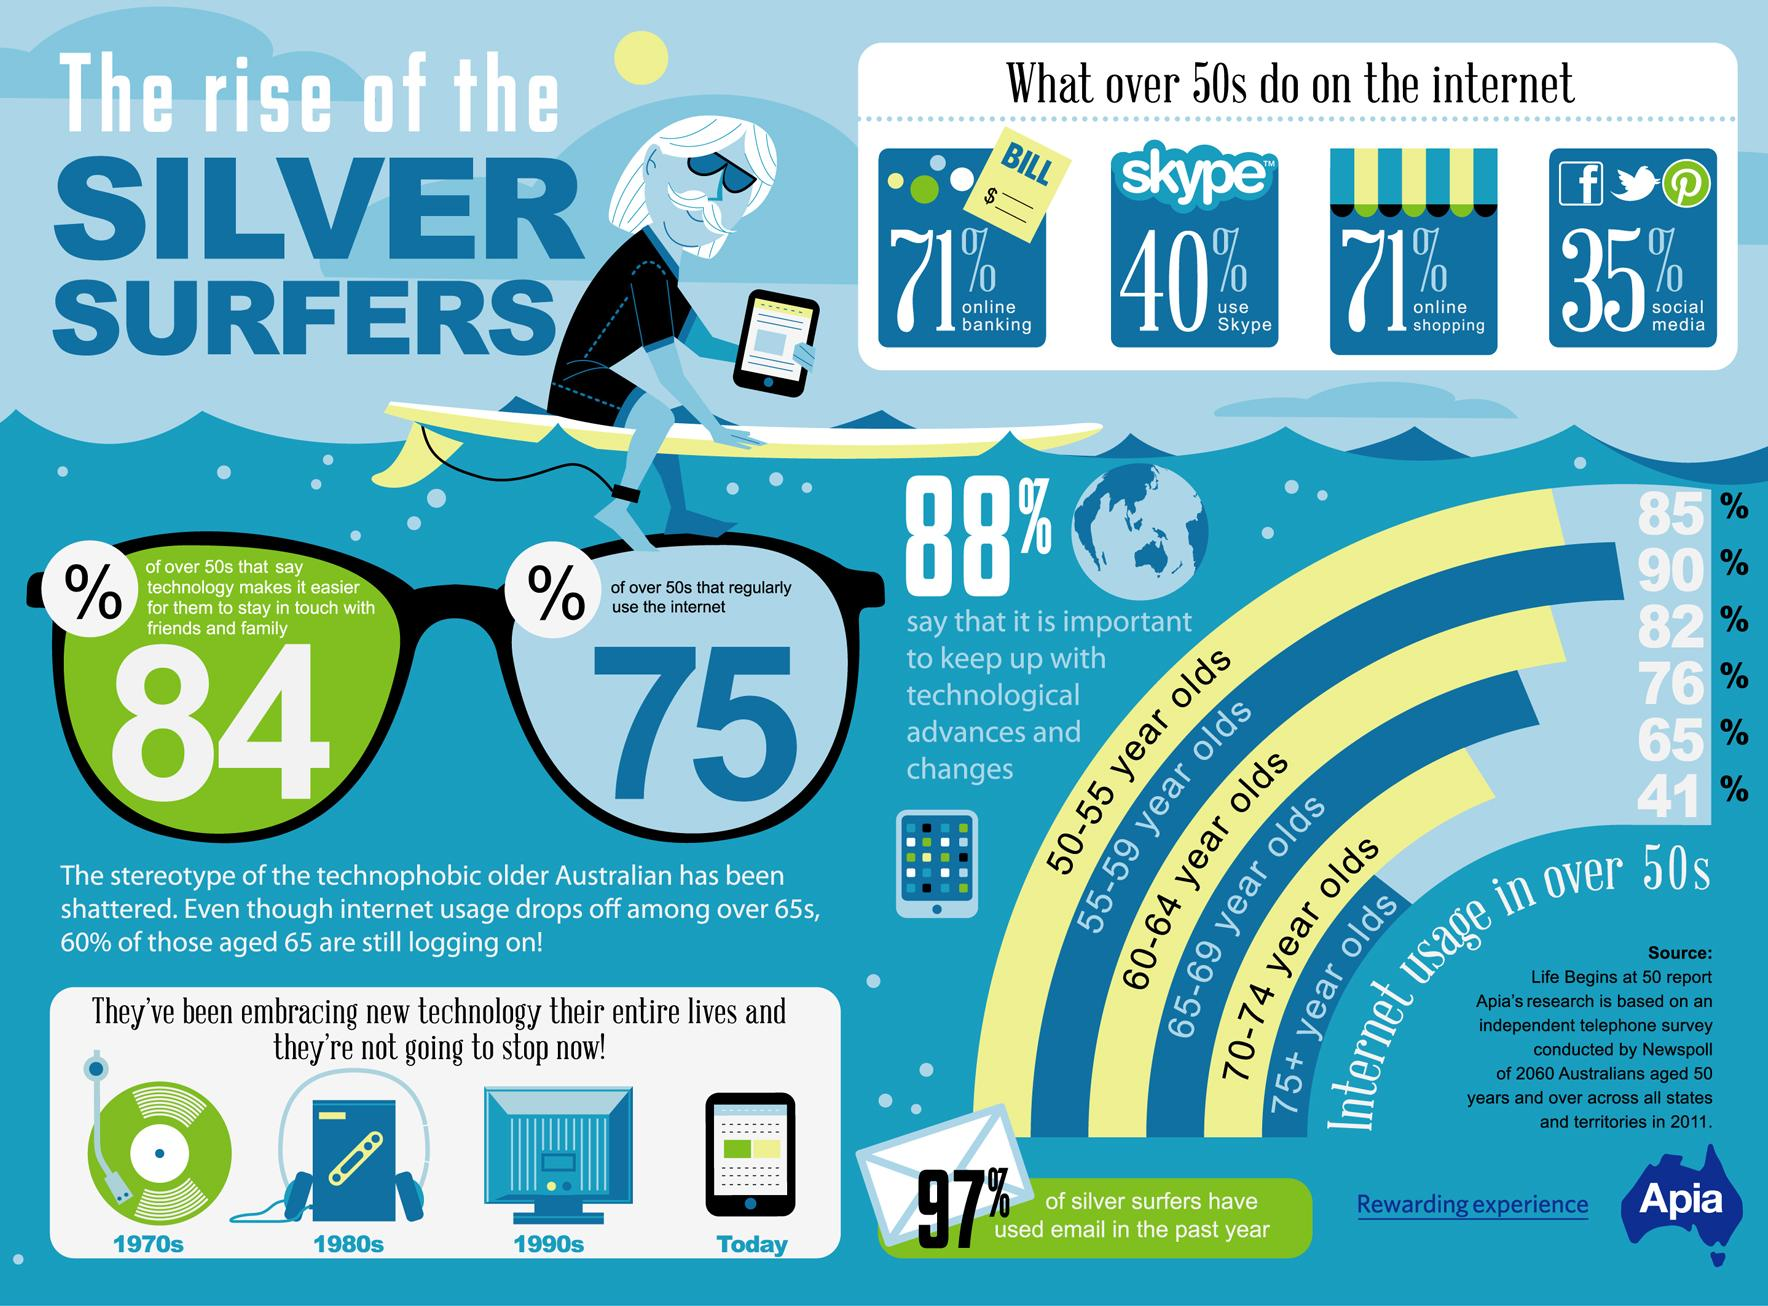Specify some key components in this picture. In the 2011 survey, it was found that 75% of Australians aged over 50 regularly use the internet. According to the 2011 survey, only 12% of Australians aged over 50 stated that it is not important to keep up with technological advances and changes. According to the 2011 survey, 90% of Australians aged 55-59 years use the internet. According to a survey conducted in 2011, 82% of Australians aged 60-64 years reported using the internet. According to a 2011 survey, 35% of Australians aged over 50 use social media. 